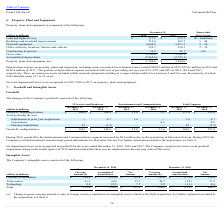According to Cincinnati Bell's financial document, How many years is the minimum lifespan of the land and rights-of-way? According to the financial document, 20. The relevant text states: "(dollars in millions) 2019 2018 Lives (Years)..." Also, can you calculate: What is the total depreciation expense incurred by the company between 2017 to 2019? Based on the calculation: $(290.2 + 239.6 + 190.4) , the result is 720.2 (in millions). This is based on the information: "finance leases, totaled $290.2 million in 2019, $239.6 million in 2018 and $190.4 million in 2017. The portion of depreciation expense associated with cos 90.2 million in 2019, $239.6 million in 2018 ..." The key data points involved are: 190.4, 239.6, 290.2. Also, can you calculate: What is the change in accumulated depreciation for PPE between December 31, 2018 and 2019? To answer this question, I need to perform calculations using the financial data. The calculation is: (2,964.6 - 2,755.1)/2,755.1 , which equals 7.6 (percentage). This is based on the information: "Accumulated depreciation (2,964.6) (2,755.1) Accumulated depreciation (2,964.6) (2,755.1)..." The key data points involved are: 2,755.1, 2,964.6. Also, What is the asset impairment loss recognised by the company on PPE between 2017 to 2019? According to the financial document, 0. The relevant text states: "Table of Contents Form 10-K Part II Cincinnati Bell Inc. Table of Contents Form 10-K Part II Cincinnati Bell Inc. Table of Contents Form 10-K Part II Cincinnati Bell Inc...." Also, What is the portion of depreciation expense associated with cost of providing services in 2019? According to the financial document, 87%. The relevant text states: "nse associated with cost of providing services was 87%, 85% and 84% in 2019, 2018 and 2017, respectively. There are numerous assets included within networ..." Also, can you calculate: What is the total network equiption between 2018 to 2019? Based on the calculation: 4,044.6+3,913.3, the result is 7957.9 (in millions). This is based on the information: "Network equipment 4,044.6 3,913.3 2 – 50 Network equipment 4,044.6 3,913.3 2 – 50..." The key data points involved are: 3,913.3, 4,044.6. 